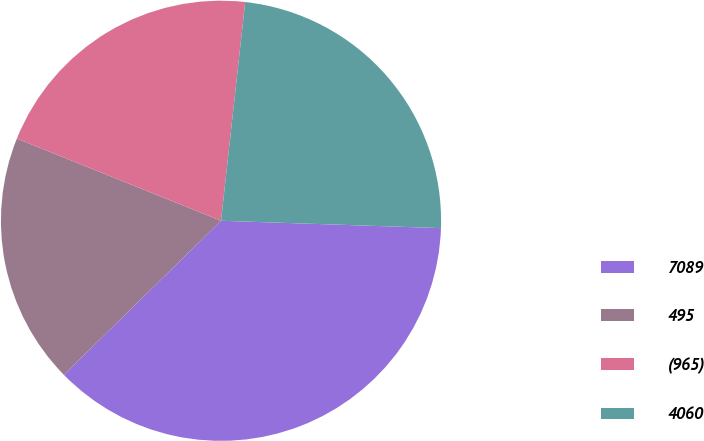Convert chart to OTSL. <chart><loc_0><loc_0><loc_500><loc_500><pie_chart><fcel>7089<fcel>495<fcel>(965)<fcel>4060<nl><fcel>37.13%<fcel>18.43%<fcel>20.66%<fcel>23.78%<nl></chart> 